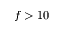<formula> <loc_0><loc_0><loc_500><loc_500>f > 1 0</formula> 